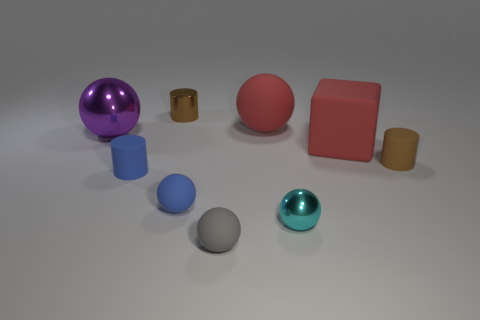Subtract 1 balls. How many balls are left? 4 Subtract all gray matte balls. How many balls are left? 4 Subtract all blue balls. How many balls are left? 4 Subtract all brown balls. Subtract all purple cylinders. How many balls are left? 5 Subtract all spheres. How many objects are left? 4 Add 4 blue cylinders. How many blue cylinders are left? 5 Add 4 tiny purple matte cubes. How many tiny purple matte cubes exist? 4 Subtract 0 green spheres. How many objects are left? 9 Subtract all brown metal cylinders. Subtract all big purple things. How many objects are left? 7 